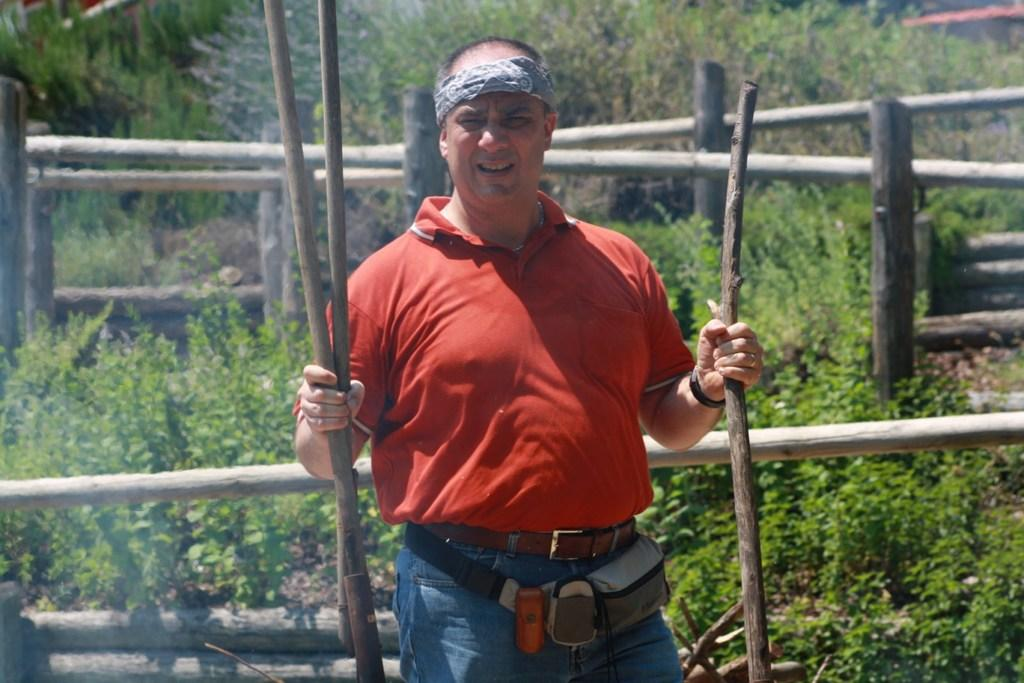What is the main subject of the image? There is a man standing in the image. What is the man holding in his hands? The man is holding wooden sticks in both hands. What can be seen in the background of the image? There are plants, trees, and wooden fences in the background of the image. What type of sugar is being mined in the image? There is no mine or sugar present in the image. Is there a camera visible in the image? There is no camera visible in the image. 